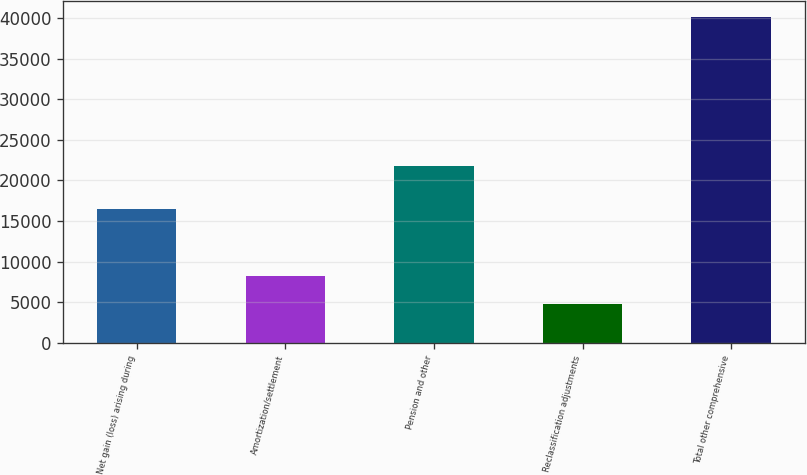Convert chart to OTSL. <chart><loc_0><loc_0><loc_500><loc_500><bar_chart><fcel>Net gain (loss) arising during<fcel>Amortization/settlement<fcel>Pension and other<fcel>Reclassification adjustments<fcel>Total other comprehensive<nl><fcel>16415<fcel>8274<fcel>21788<fcel>4738<fcel>40098<nl></chart> 